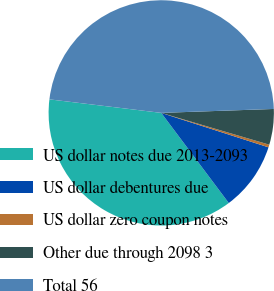Convert chart to OTSL. <chart><loc_0><loc_0><loc_500><loc_500><pie_chart><fcel>US dollar notes due 2013-2093<fcel>US dollar debentures due<fcel>US dollar zero coupon notes<fcel>Other due through 2098 3<fcel>Total 56<nl><fcel>37.15%<fcel>9.82%<fcel>0.39%<fcel>5.11%<fcel>47.53%<nl></chart> 